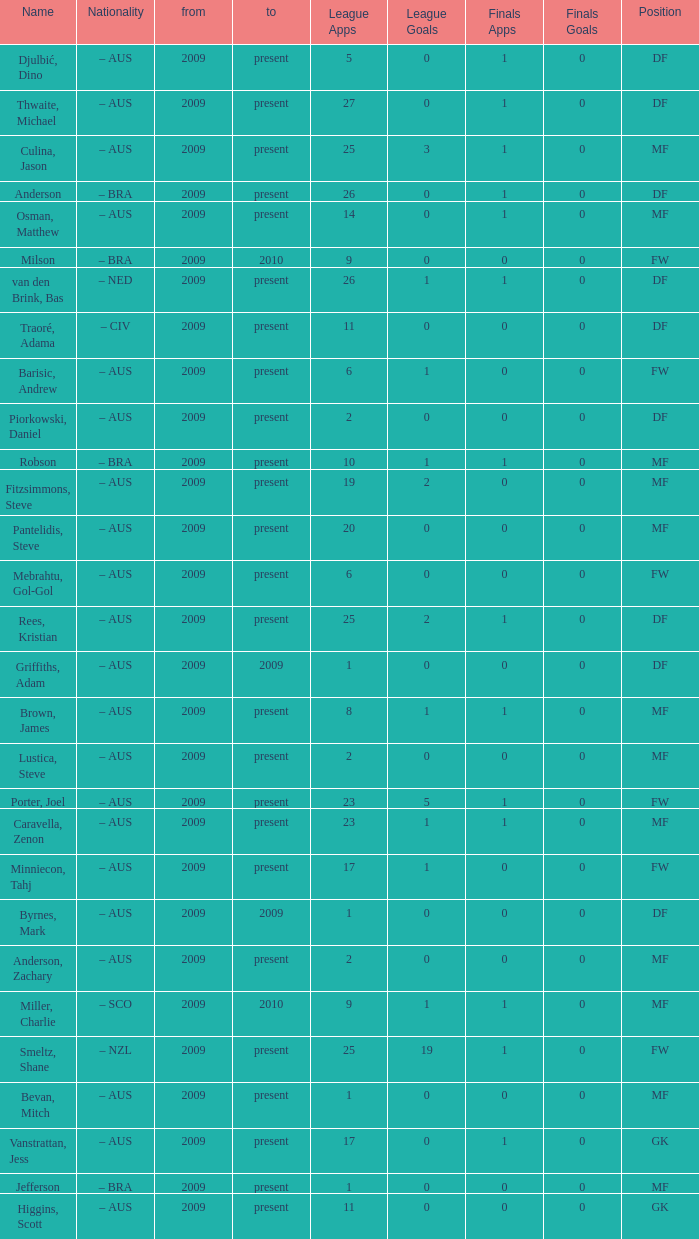Name the mosst finals apps 1.0. 